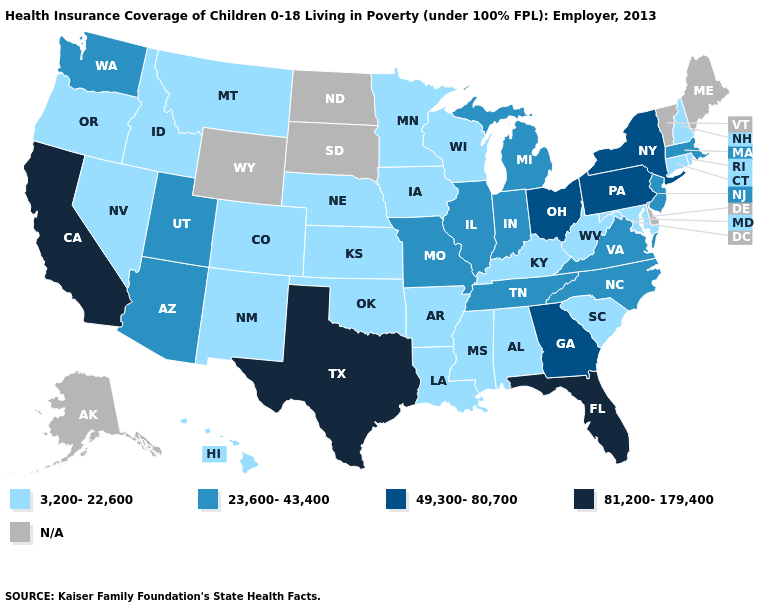What is the highest value in states that border California?
Keep it brief. 23,600-43,400. What is the highest value in the Northeast ?
Write a very short answer. 49,300-80,700. Among the states that border Indiana , which have the highest value?
Answer briefly. Ohio. What is the highest value in states that border Virginia?
Be succinct. 23,600-43,400. Name the states that have a value in the range 3,200-22,600?
Answer briefly. Alabama, Arkansas, Colorado, Connecticut, Hawaii, Idaho, Iowa, Kansas, Kentucky, Louisiana, Maryland, Minnesota, Mississippi, Montana, Nebraska, Nevada, New Hampshire, New Mexico, Oklahoma, Oregon, Rhode Island, South Carolina, West Virginia, Wisconsin. What is the value of New Jersey?
Keep it brief. 23,600-43,400. What is the highest value in states that border Ohio?
Concise answer only. 49,300-80,700. Name the states that have a value in the range 81,200-179,400?
Keep it brief. California, Florida, Texas. Which states have the lowest value in the USA?
Answer briefly. Alabama, Arkansas, Colorado, Connecticut, Hawaii, Idaho, Iowa, Kansas, Kentucky, Louisiana, Maryland, Minnesota, Mississippi, Montana, Nebraska, Nevada, New Hampshire, New Mexico, Oklahoma, Oregon, Rhode Island, South Carolina, West Virginia, Wisconsin. Does West Virginia have the highest value in the South?
Quick response, please. No. Name the states that have a value in the range 81,200-179,400?
Answer briefly. California, Florida, Texas. What is the value of New Mexico?
Short answer required. 3,200-22,600. What is the value of California?
Be succinct. 81,200-179,400. 